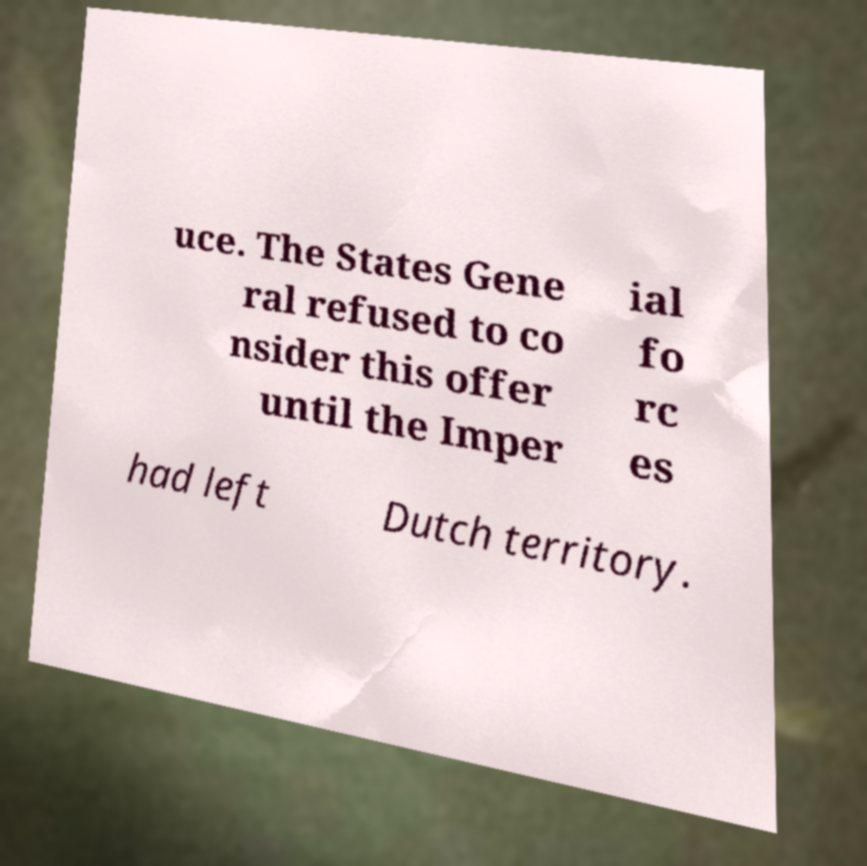Could you assist in decoding the text presented in this image and type it out clearly? uce. The States Gene ral refused to co nsider this offer until the Imper ial fo rc es had left Dutch territory. 